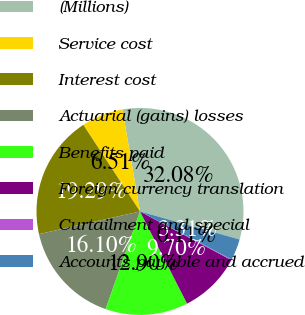Convert chart to OTSL. <chart><loc_0><loc_0><loc_500><loc_500><pie_chart><fcel>(Millions)<fcel>Service cost<fcel>Interest cost<fcel>Actuarial (gains) losses<fcel>Benefits paid<fcel>Foreign currency translation<fcel>Curtailment and special<fcel>Accounts payable and accrued<nl><fcel>32.08%<fcel>6.51%<fcel>19.29%<fcel>16.1%<fcel>12.9%<fcel>9.7%<fcel>0.11%<fcel>3.31%<nl></chart> 